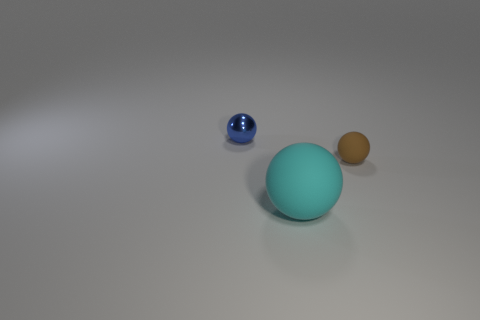Subtract all small balls. How many balls are left? 1 Add 1 large cyan shiny cylinders. How many objects exist? 4 Subtract all small green matte blocks. Subtract all large cyan matte things. How many objects are left? 2 Add 2 blue metal spheres. How many blue metal spheres are left? 3 Add 2 small metallic things. How many small metallic things exist? 3 Subtract 0 yellow cubes. How many objects are left? 3 